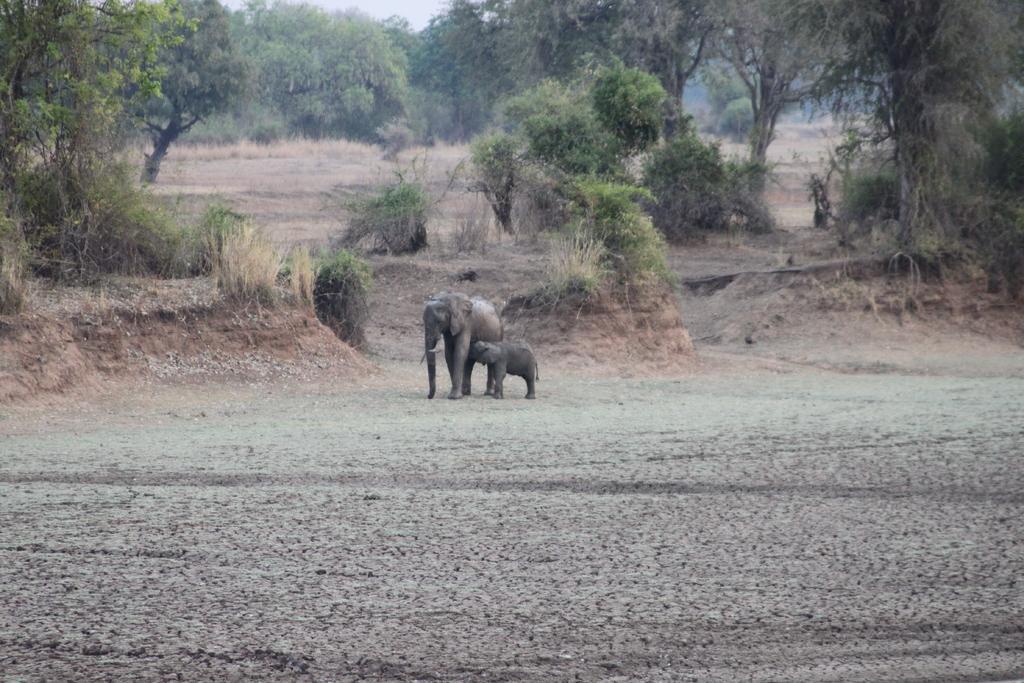In one or two sentences, can you explain what this image depicts? In this image there are two elephants standing on the surface and in the background there are trees and the sky. 